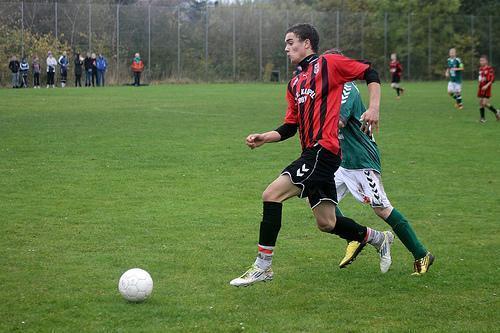How many balls are used in this game?
Give a very brief answer. 1. How many players are wearing a green shirt?
Give a very brief answer. 2. 